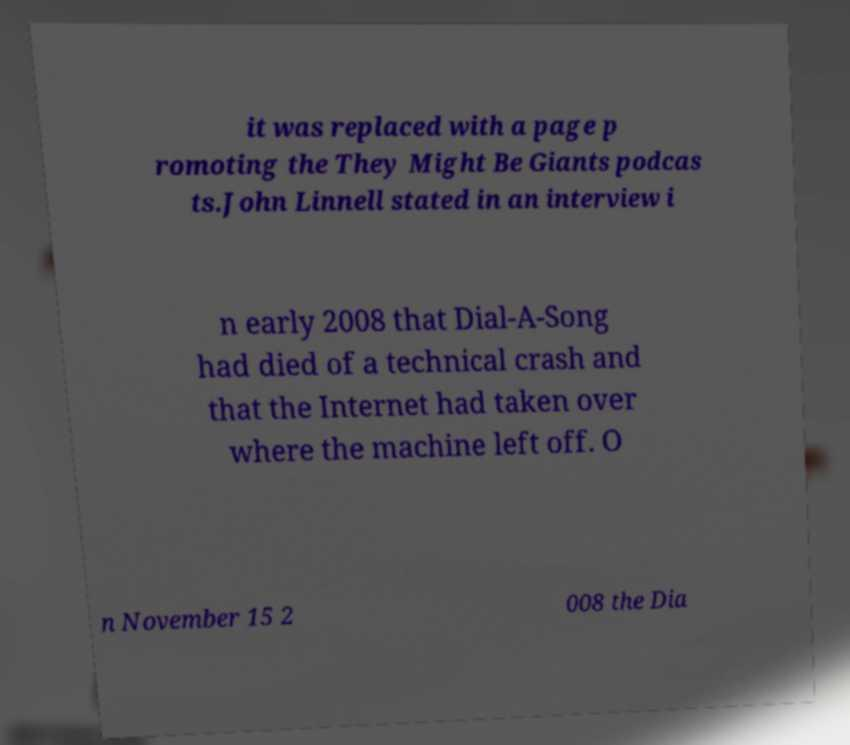Could you assist in decoding the text presented in this image and type it out clearly? it was replaced with a page p romoting the They Might Be Giants podcas ts.John Linnell stated in an interview i n early 2008 that Dial-A-Song had died of a technical crash and that the Internet had taken over where the machine left off. O n November 15 2 008 the Dia 